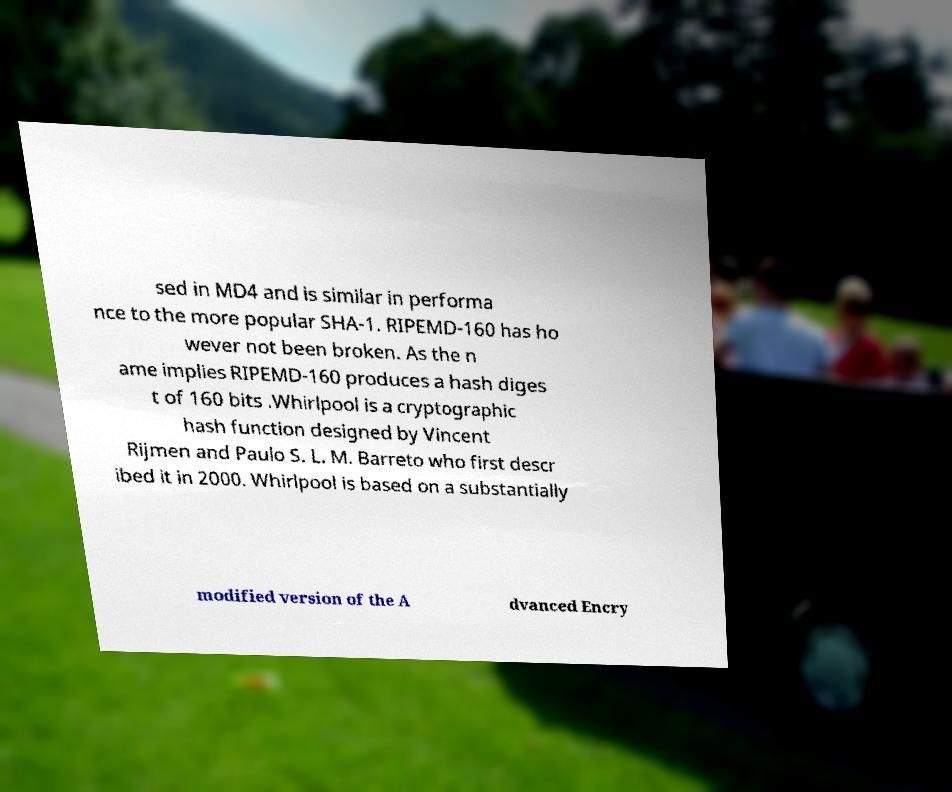I need the written content from this picture converted into text. Can you do that? sed in MD4 and is similar in performa nce to the more popular SHA-1. RIPEMD-160 has ho wever not been broken. As the n ame implies RIPEMD-160 produces a hash diges t of 160 bits .Whirlpool is a cryptographic hash function designed by Vincent Rijmen and Paulo S. L. M. Barreto who first descr ibed it in 2000. Whirlpool is based on a substantially modified version of the A dvanced Encry 